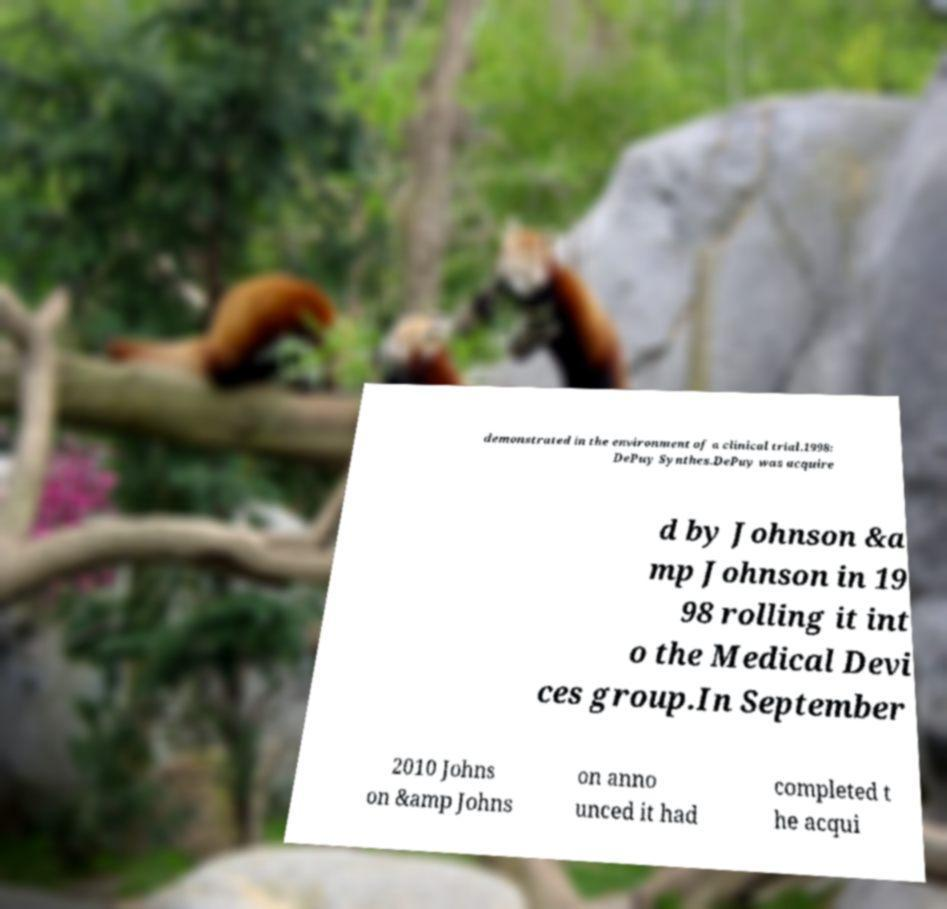Can you read and provide the text displayed in the image?This photo seems to have some interesting text. Can you extract and type it out for me? demonstrated in the environment of a clinical trial.1998: DePuy Synthes.DePuy was acquire d by Johnson &a mp Johnson in 19 98 rolling it int o the Medical Devi ces group.In September 2010 Johns on &amp Johns on anno unced it had completed t he acqui 